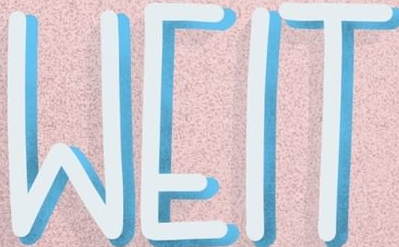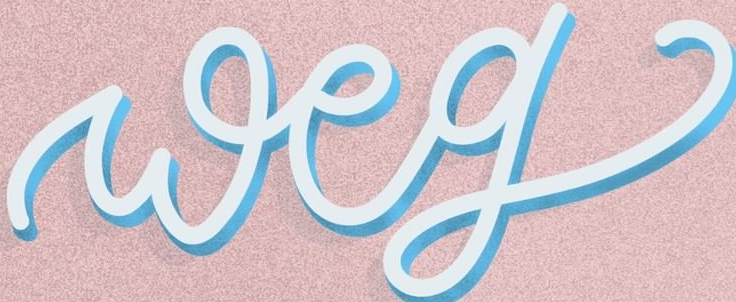Read the text content from these images in order, separated by a semicolon. WEIT; weg 